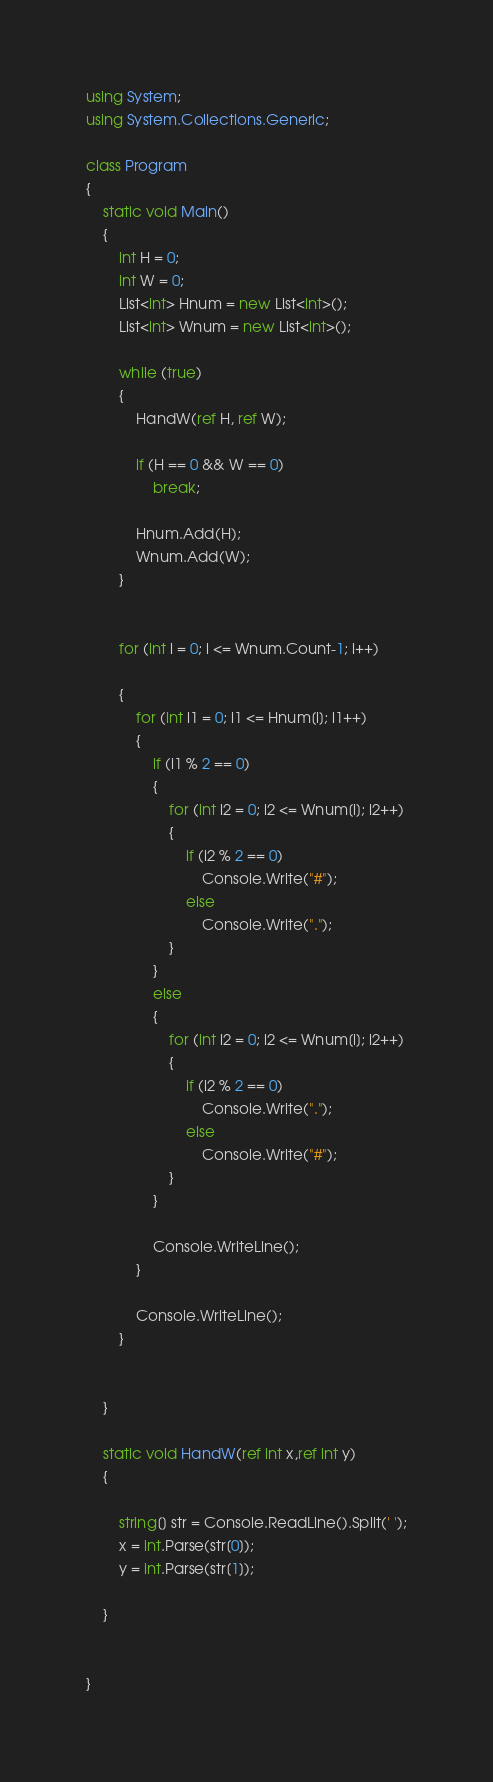<code> <loc_0><loc_0><loc_500><loc_500><_C#_>using System;
using System.Collections.Generic;

class Program
{
    static void Main()
    {
        int H = 0;
        int W = 0;
        List<int> Hnum = new List<int>();
        List<int> Wnum = new List<int>();

        while (true)
        {
            HandW(ref H, ref W);

            if (H == 0 && W == 0)
                break;

            Hnum.Add(H);
            Wnum.Add(W);
        }


        for (int i = 0; i <= Wnum.Count-1; i++)

        {
            for (int i1 = 0; i1 <= Hnum[i]; i1++)
            {
                if (i1 % 2 == 0)
                {
                    for (int i2 = 0; i2 <= Wnum[i]; i2++)
                    {
                        if (i2 % 2 == 0)
                            Console.Write("#");
                        else
                            Console.Write(".");
                    }
                }
                else
                {
                    for (int i2 = 0; i2 <= Wnum[i]; i2++)
                    {
                        if (i2 % 2 == 0)
                            Console.Write(".");
                        else
                            Console.Write("#");
                    }
                }

                Console.WriteLine();
            }

            Console.WriteLine();
        }


    }

    static void HandW(ref int x,ref int y)
    {
      
        string[] str = Console.ReadLine().Split(' ');
        x = int.Parse(str[0]);
        y = int.Parse(str[1]);
  
    }

   
}</code> 